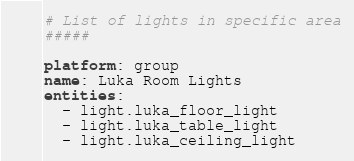<code> <loc_0><loc_0><loc_500><loc_500><_YAML_># List of lights in specific area
#####

platform: group
name: Luka Room Lights
entities:
  - light.luka_floor_light
  - light.luka_table_light
  - light.luka_ceiling_light
</code> 